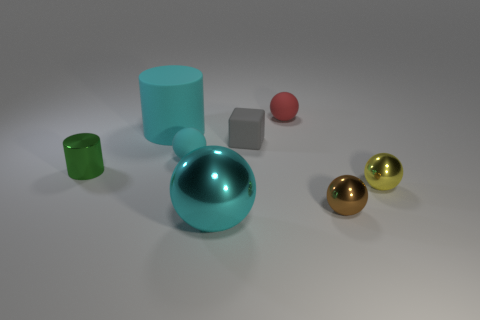Subtract all small brown spheres. How many spheres are left? 4 Add 1 large cylinders. How many objects exist? 9 Subtract all cyan cylinders. How many cylinders are left? 1 Subtract all cylinders. How many objects are left? 6 Subtract 1 cylinders. How many cylinders are left? 1 Subtract all green cylinders. How many cyan balls are left? 2 Subtract all big red matte cylinders. Subtract all cylinders. How many objects are left? 6 Add 3 brown objects. How many brown objects are left? 4 Add 5 tiny brown shiny balls. How many tiny brown shiny balls exist? 6 Subtract 0 yellow blocks. How many objects are left? 8 